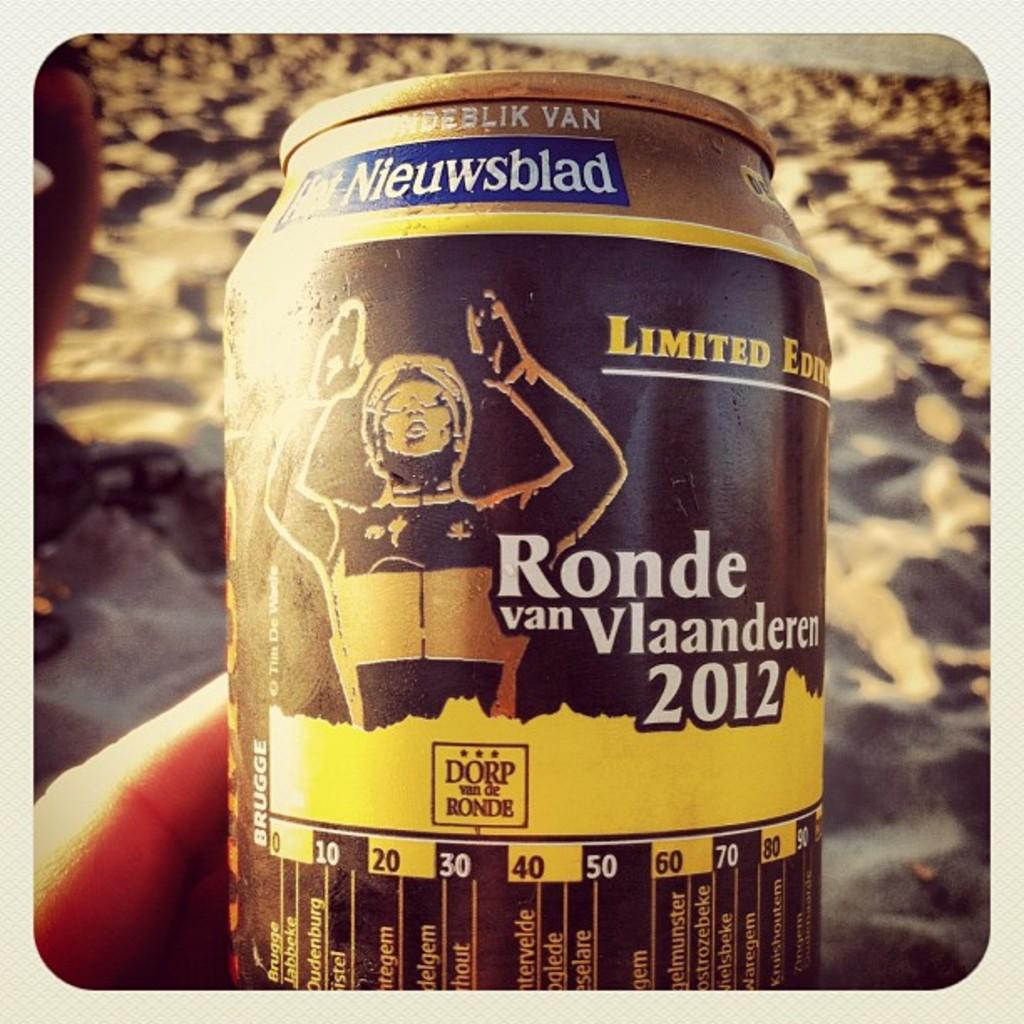<image>
Provide a brief description of the given image. a can that has the word Ronde in it 